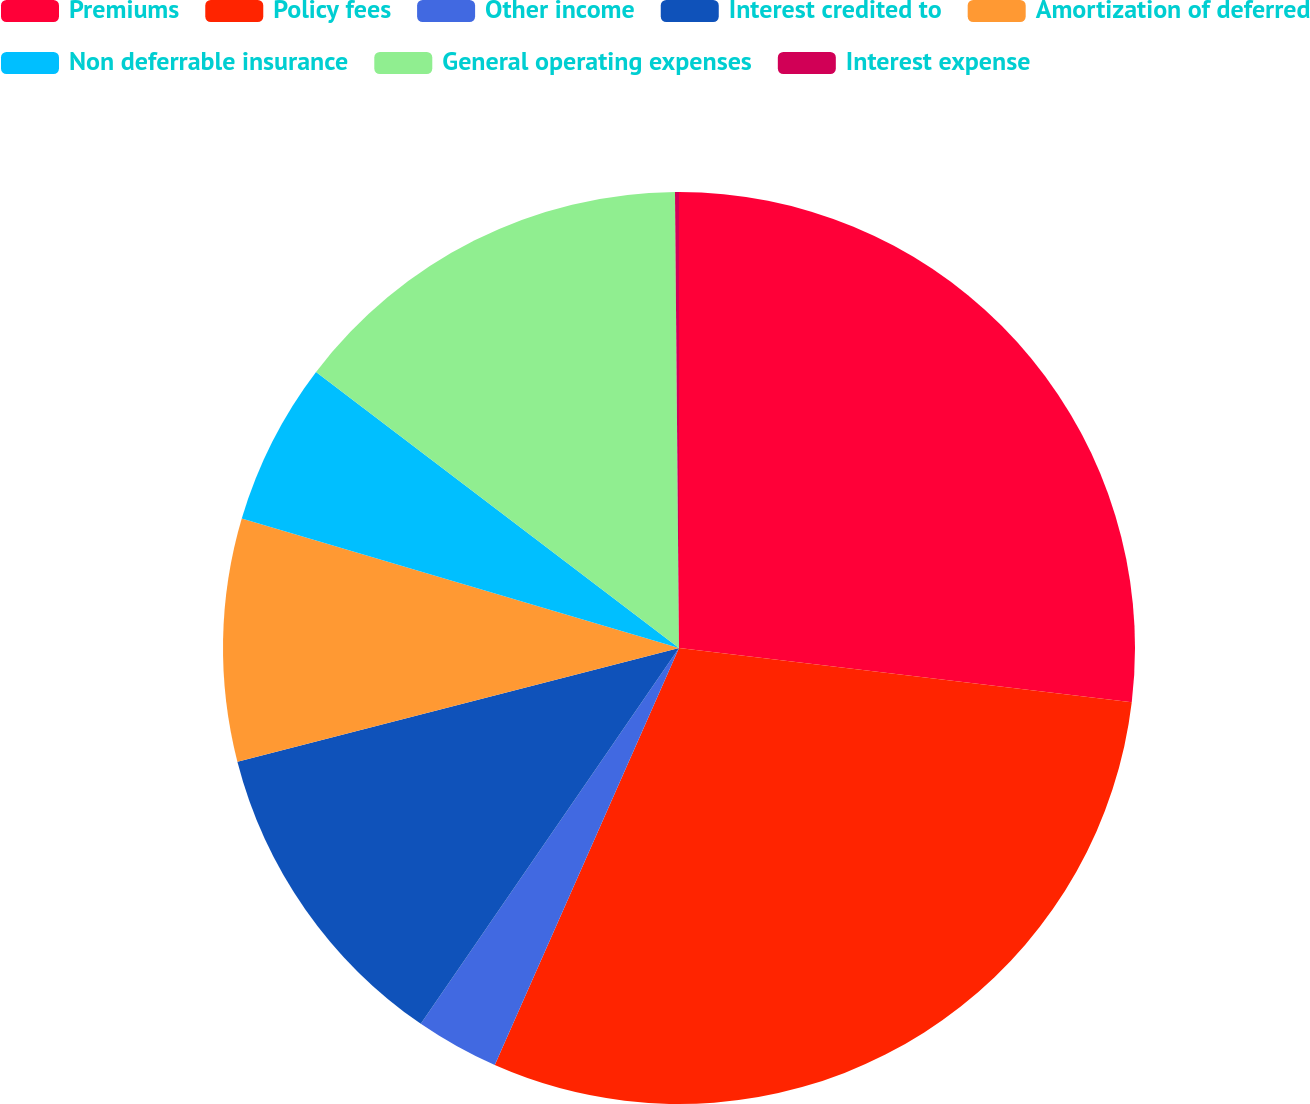Convert chart. <chart><loc_0><loc_0><loc_500><loc_500><pie_chart><fcel>Premiums<fcel>Policy fees<fcel>Other income<fcel>Interest credited to<fcel>Amortization of deferred<fcel>Non deferrable insurance<fcel>General operating expenses<fcel>Interest expense<nl><fcel>26.9%<fcel>29.72%<fcel>2.96%<fcel>11.41%<fcel>8.59%<fcel>5.77%<fcel>14.51%<fcel>0.14%<nl></chart> 